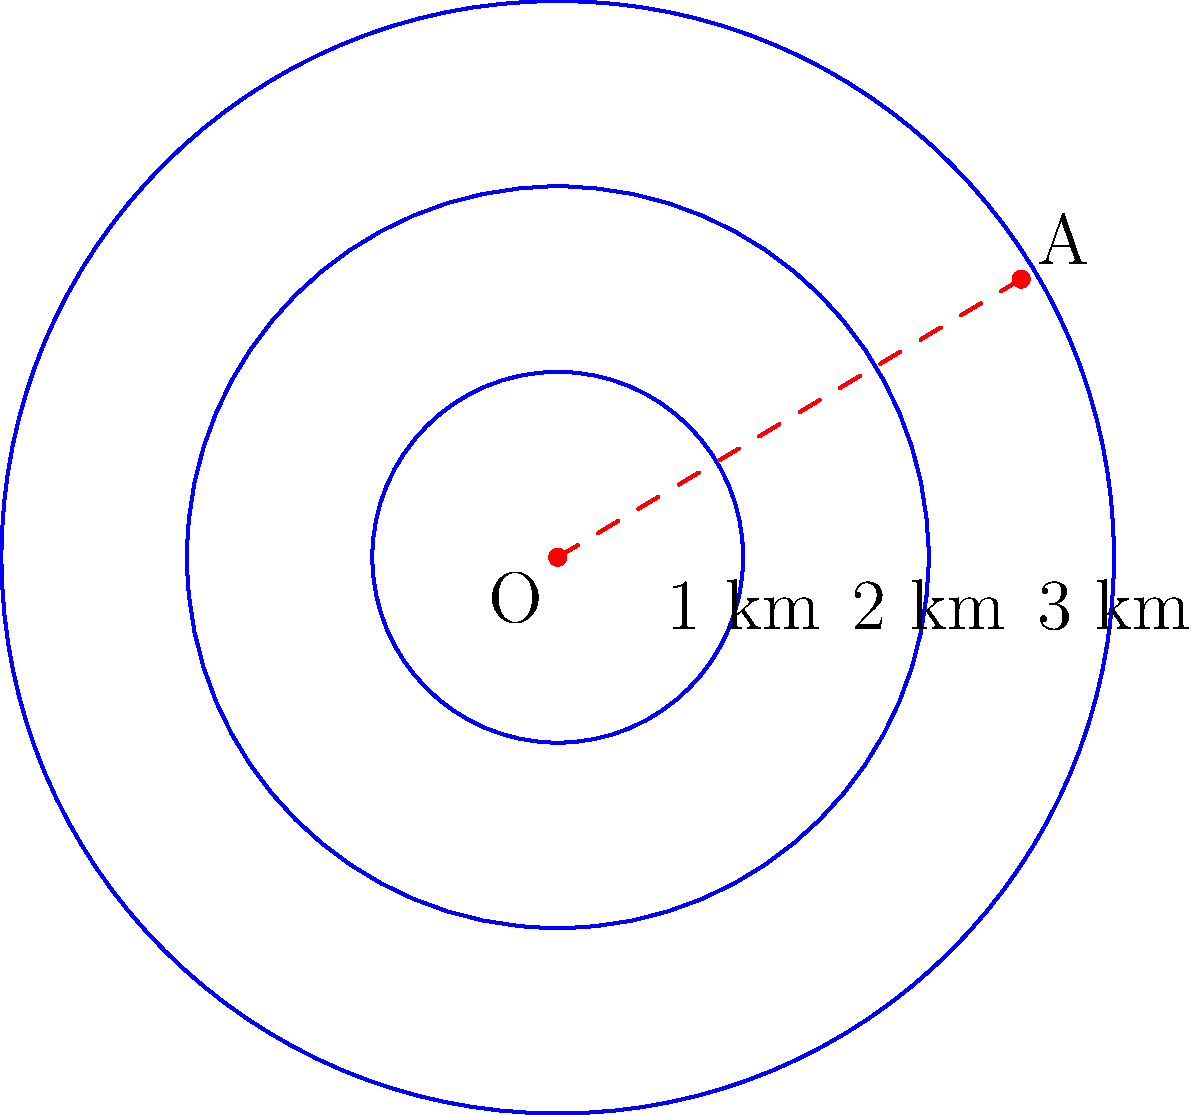In a study of population displacement due to gentrification in the East End, concentric circles are drawn at 1 km intervals from a central point O. A displaced household is located at point A. If the density of displacement is measured as the number of households per square kilometer, how does the density measurement change when considering the area between the 2 km and 3 km circles compared to the area between the 1 km and 2 km circles? Assume the household at A is the only one displaced in this region. To solve this problem, we need to follow these steps:

1) First, calculate the areas of the regions:
   - Area between 1 km and 2 km circles: $A_1 = \pi(2^2 - 1^2) = 3\pi$ km²
   - Area between 2 km and 3 km circles: $A_2 = \pi(3^2 - 2^2) = 5\pi$ km²

2) The density is calculated as the number of households divided by the area.

3) In this case, we have one household (at point A) in the region between the 2 km and 3 km circles.

4) The density in the 2-3 km region is:
   $D_2 = \frac{1}{5\pi}$ households/km²

5) The density in the 1-2 km region is:
   $D_1 = \frac{0}{3\pi} = 0$ households/km²

6) To compare the densities, we can divide $D_2$ by $D_1$:
   $\frac{D_2}{D_1} = \frac{\frac{1}{5\pi}}{0} = \text{undefined}$

7) However, we can say that the density increases from 0 to a positive value, which represents an infinite percentage increase.
Answer: The density increases from 0 to $\frac{1}{5\pi}$ households/km², an infinite percentage increase. 